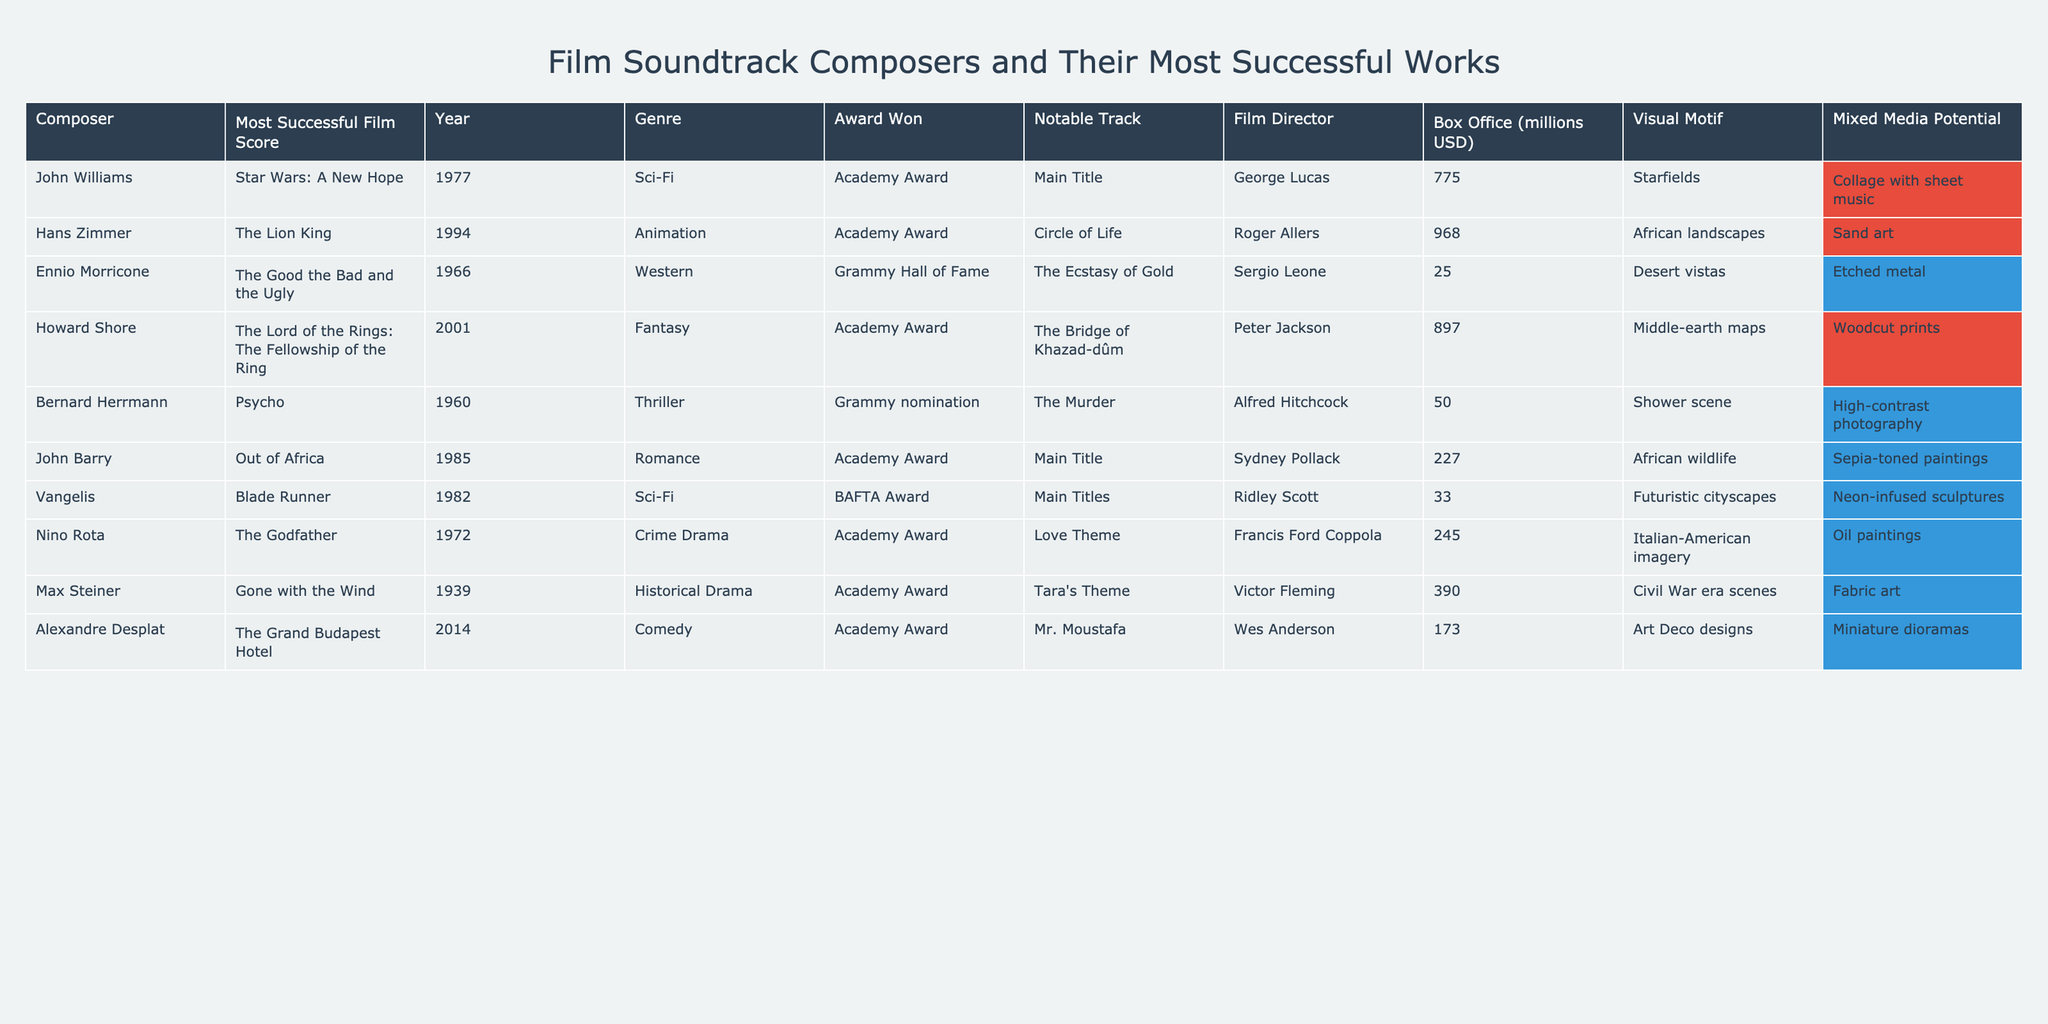What film score by John Williams won an Academy Award? The table shows that John Williams' most successful film score is "Star Wars: A New Hope," which he won an Academy Award for.
Answer: Star Wars: A New Hope Which composer has the highest box office collection for their film score? Looking at the 'Box Office (millions USD)' column, Hans Zimmer's "The Lion King" has the highest collection of 968 million USD.
Answer: Hans Zimmer What is the genre of the film "The Good the Bad and the Ugly"? The 'Genre' column indicates that "The Good the Bad and the Ugly" falls under the Western genre.
Answer: Western Did Howard Shore win any awards for his work on "The Lord of the Rings: The Fellowship of the Ring"? The table lists that Howard Shore won an Academy Award for "The Lord of the Rings: The Fellowship of the Ring."
Answer: Yes What is the average box office collection of the composers listed? To find the average, sum the box office collections: 775 + 968 + 25 + 897 + 50 + 227 + 33 + 245 + 390 + 173 = 3283. Then divide by the number of composers (10): 3283 / 10 = 328.3 million USD.
Answer: 328.3 million USD Which film director worked on "The Grand Budapest Hotel"? The 'Film Director' column specifies that Wes Anderson directed "The Grand Budapest Hotel."
Answer: Wes Anderson Is there a film score by Ennio Morricone that won an Academy Award? The table indicates that Ennio Morricone's "The Good the Bad and the Ugly" is recognized, but it did not win an Academy Award; instead, it is part of the Grammy Hall of Fame.
Answer: No Compare the box office of "Out of Africa" and "Gone with the Wind". Which one made more? "Out of Africa" made 227 million USD, while "Gone with the Wind" made 390 million USD according to the 'Box Office (millions USD)' column; thus, "Gone with the Wind" made more.
Answer: Gone with the Wind What type of visual motif is associated with Vangelis' "Blade Runner"? According to the 'Visual Motif' column, "Blade Runner" is associated with "Futuristic cityscapes."
Answer: Futuristic cityscapes Which composer's notable track is "Circle of Life"? The 'Notable Track' column shows that "Circle of Life" is the notable track for composer Hans Zimmer.
Answer: Hans Zimmer 